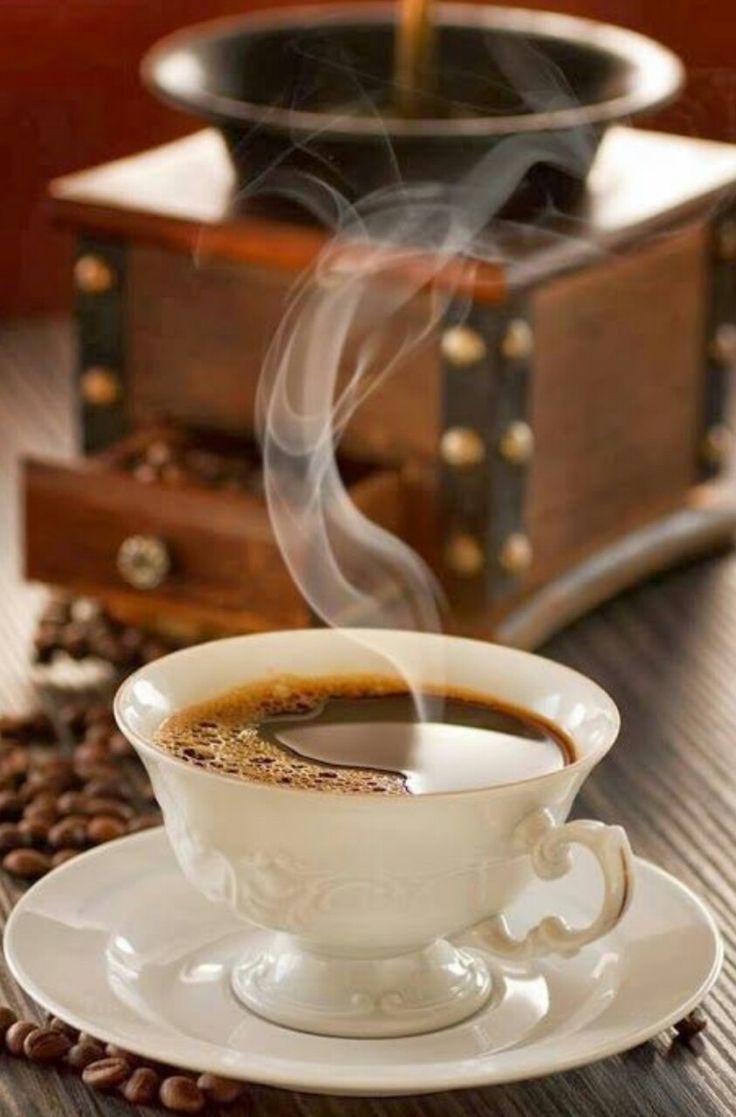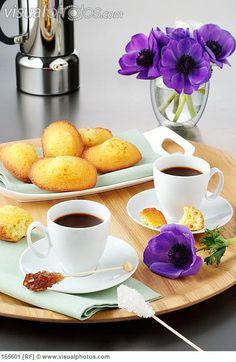The first image is the image on the left, the second image is the image on the right. Assess this claim about the two images: "In one image, a bouquet of flowers is near two cups of coffee, while the second image shows one or more cups of coffee with matching saucers.". Correct or not? Answer yes or no. Yes. The first image is the image on the left, the second image is the image on the right. Considering the images on both sides, is "An image shows a container of fresh flowers and a tray containing two filled beverage cups." valid? Answer yes or no. Yes. 